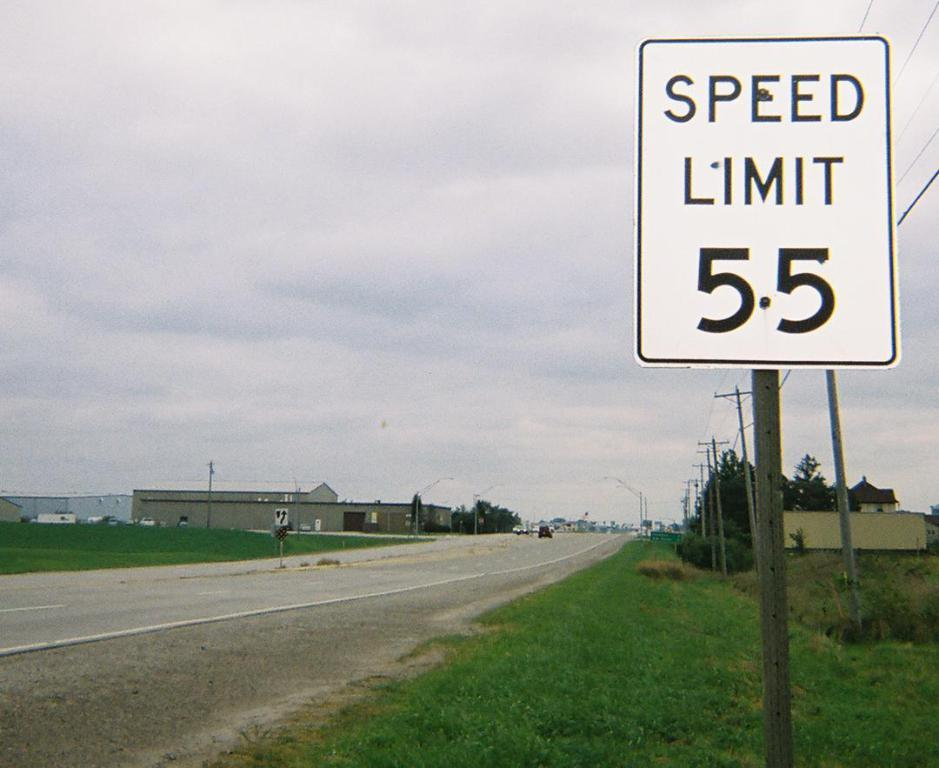<image>
Offer a succinct explanation of the picture presented. A speed limit sign with the number 55 on it. 